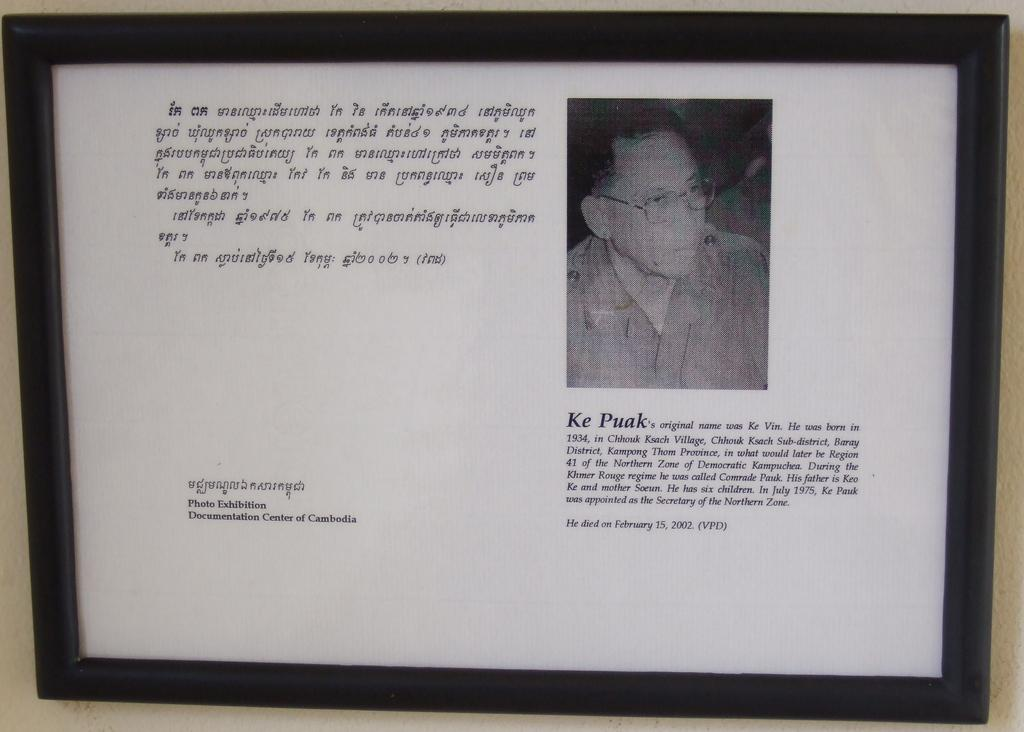<image>
Offer a succinct explanation of the picture presented. A photograph of Ke Puak has been framed in a black frame, with some text next to it. 